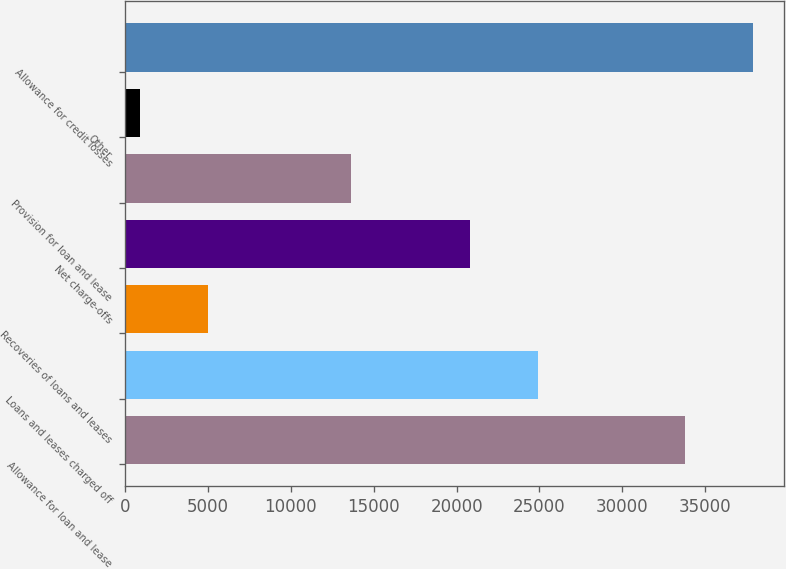Convert chart. <chart><loc_0><loc_0><loc_500><loc_500><bar_chart><fcel>Allowance for loan and lease<fcel>Loans and leases charged off<fcel>Recoveries of loans and leases<fcel>Net charge-offs<fcel>Provision for loan and lease<fcel>Other<fcel>Allowance for credit losses<nl><fcel>33783<fcel>24931.7<fcel>4996.7<fcel>20833<fcel>13629<fcel>898<fcel>37881.7<nl></chart> 